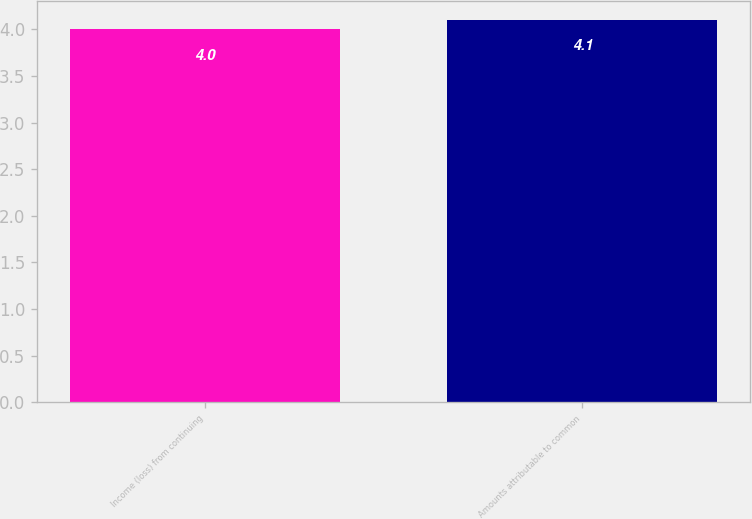<chart> <loc_0><loc_0><loc_500><loc_500><bar_chart><fcel>Income (loss) from continuing<fcel>Amounts attributable to common<nl><fcel>4<fcel>4.1<nl></chart> 